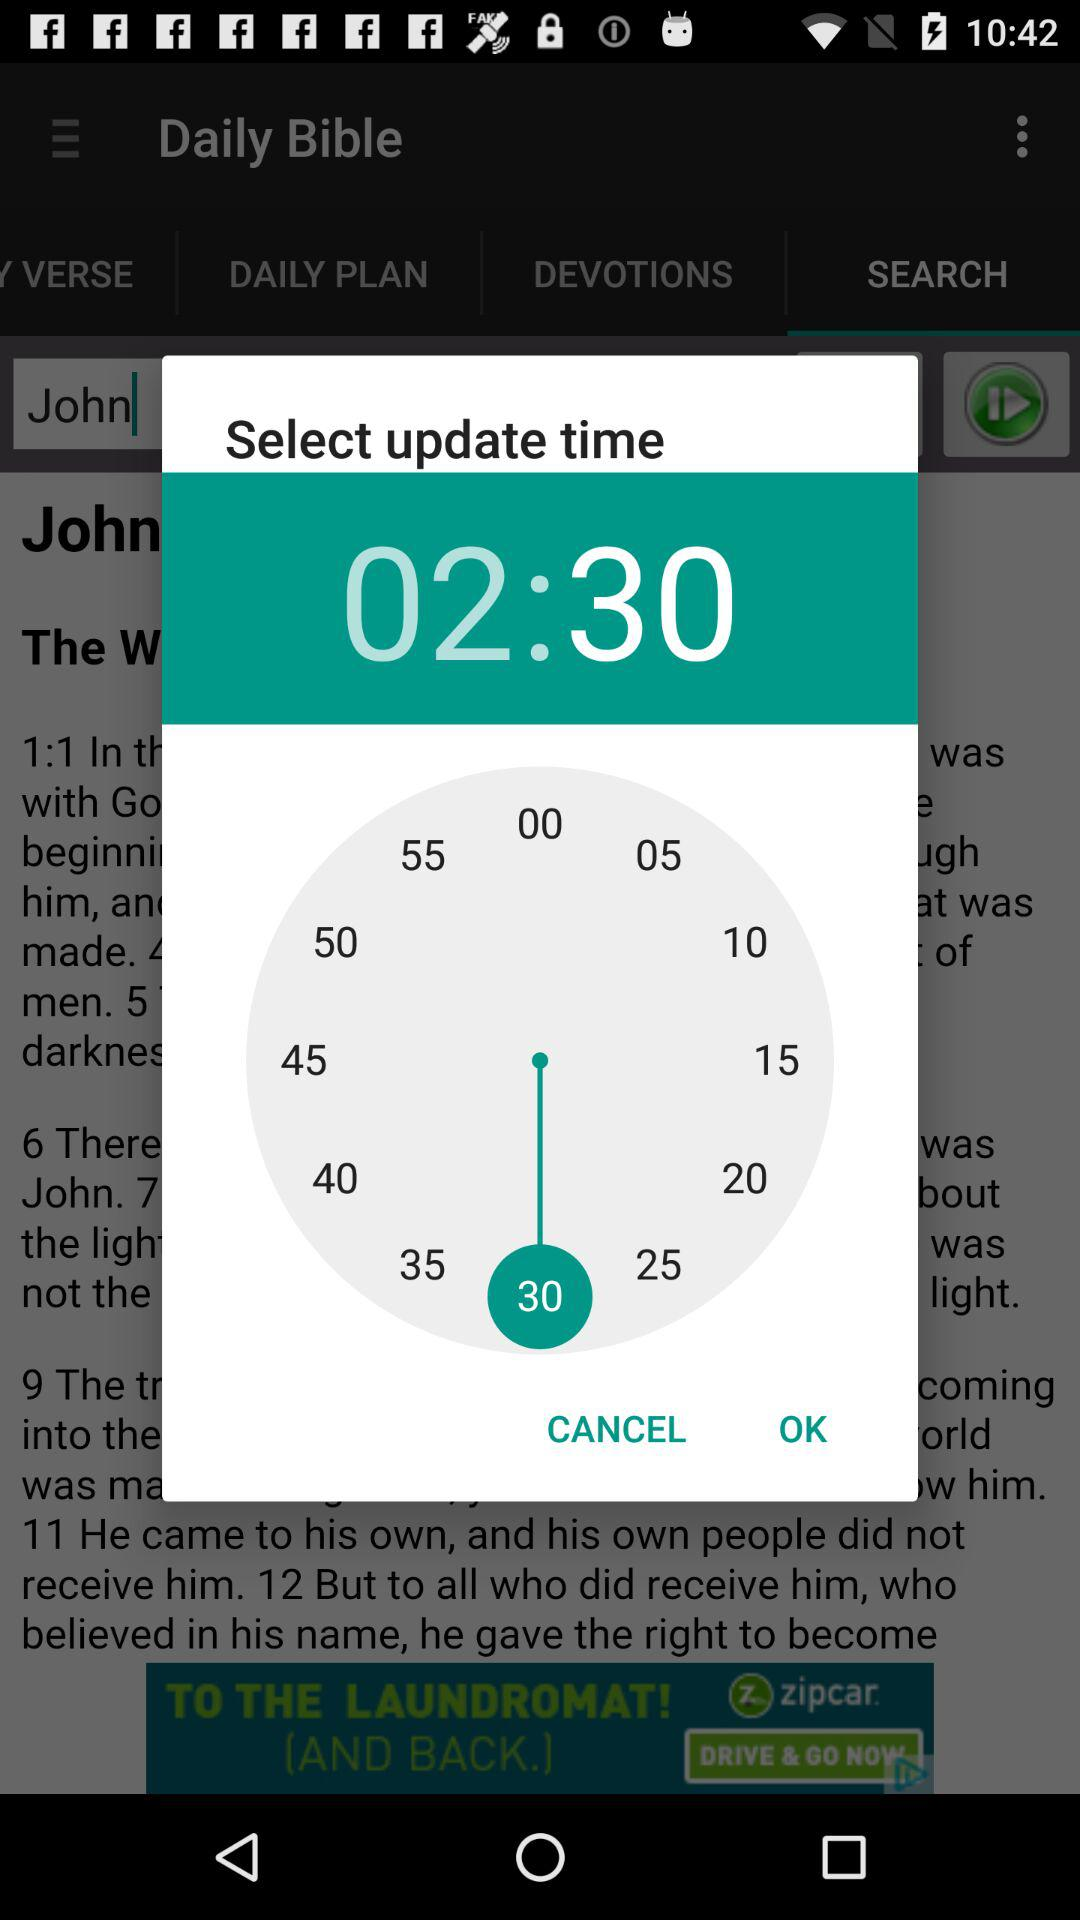What is the name in the search bar? The name in the search bar is John. 